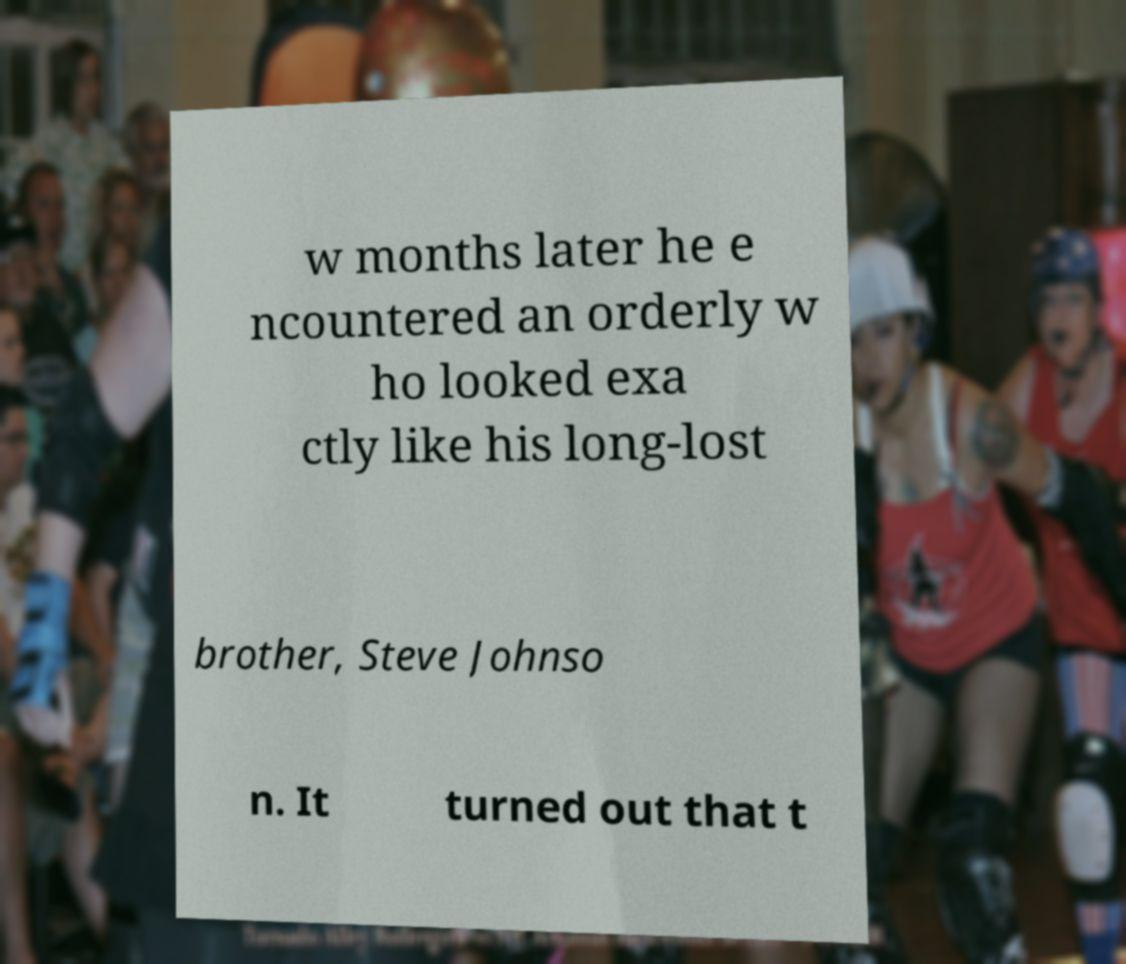Could you extract and type out the text from this image? w months later he e ncountered an orderly w ho looked exa ctly like his long-lost brother, Steve Johnso n. It turned out that t 